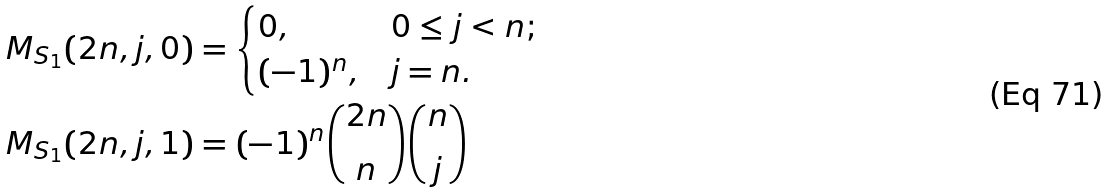<formula> <loc_0><loc_0><loc_500><loc_500>M _ { S _ { 1 } } ( 2 n , j , 0 ) & = \begin{cases} 0 , & 0 \leq j < n ; \\ ( - 1 ) ^ { n } , & j = n . \end{cases} \\ M _ { S _ { 1 } } ( 2 n , j , 1 ) & = ( - 1 ) ^ { n } \binom { 2 n } { n } \binom { n } { j }</formula> 